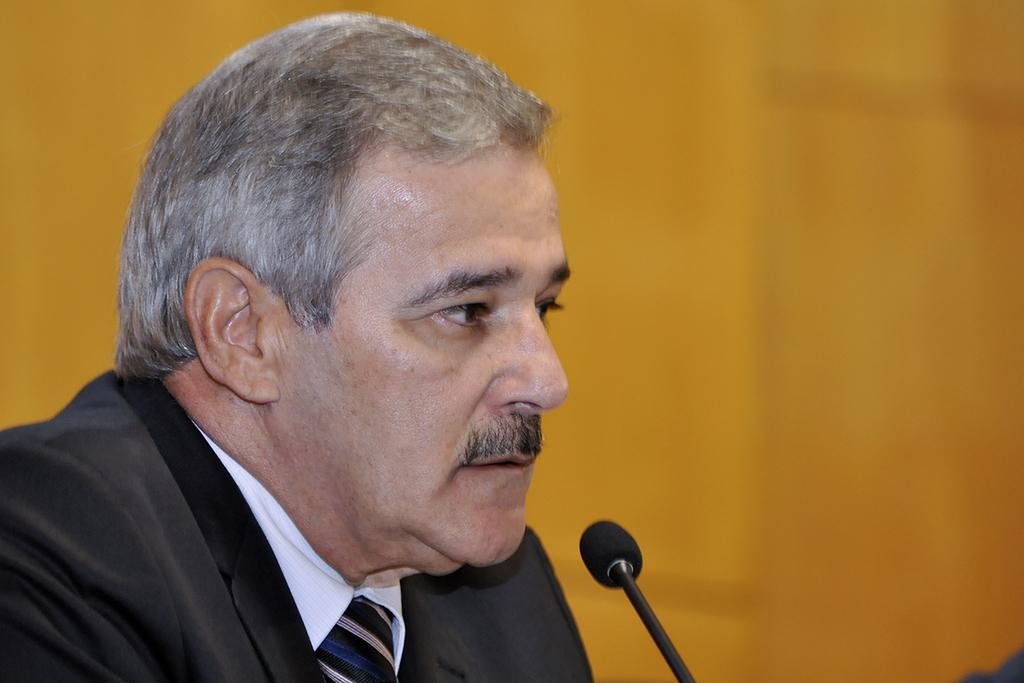Who is the main subject in the image? There is a man in the image. What object is in front of the man? There is a microphone in front of the man. What type of beast can be seen smashing the microphone in the image? There is no beast present in the image, nor is the microphone being smashed. 